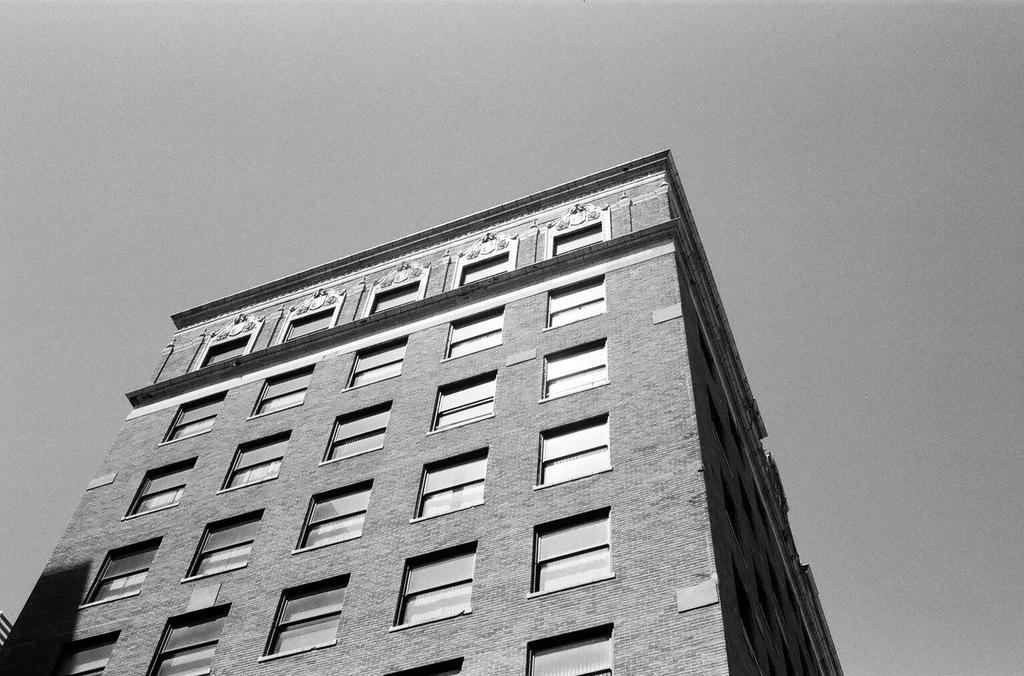What is the color scheme of the image? The image is black and white. What type of structure can be seen in the image? There is a building in the image. What can be seen in the background of the image? The sky is visible in the background of the image. How many brains can be seen hanging from the building in the image? There are no brains visible in the image; it features a building and a black and white color scheme. What type of birds are flying in the sky in the image? There are no birds visible in the image; it only features a building and the sky in the background. 